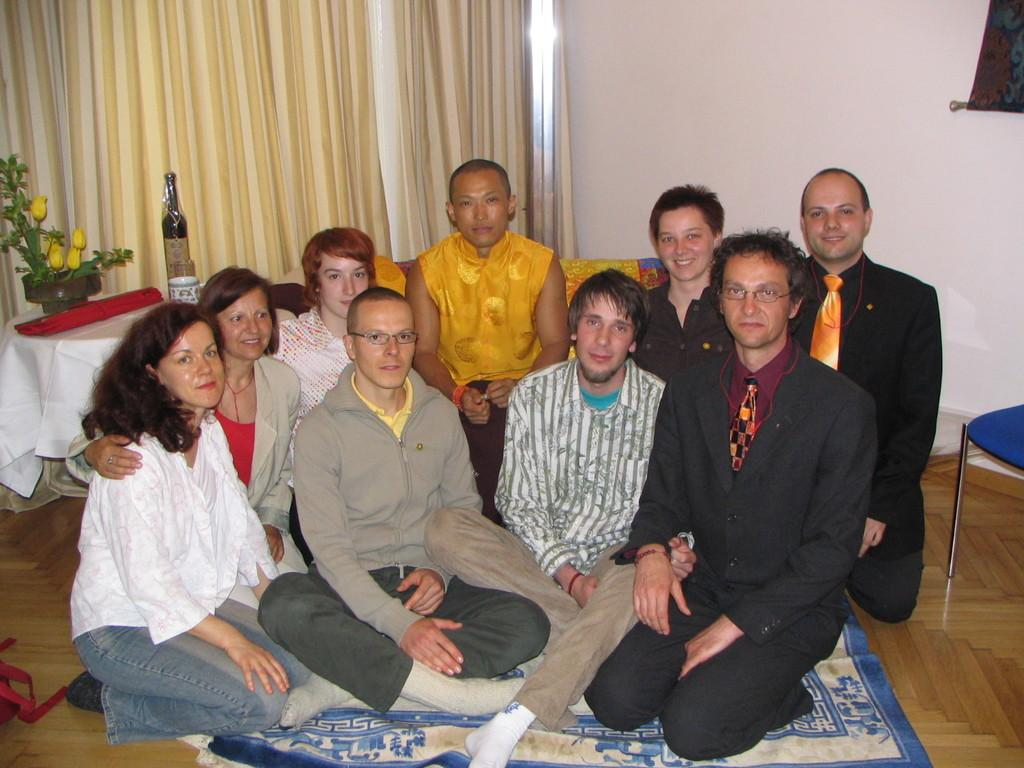What are the people in the image doing? The people in the image are sitting. Can you describe the seating arrangement of one of the people? One person is sitting on a couch. What object can be seen on a table in the image? There is a potted plant on a table. What type of window treatment is visible in the image? There is a curtain visible in the image. What type of base can be seen supporting the couch in the image? There is no base supporting the couch visible in the image; the couch is resting on the floor. How is the string used in the image? There is no string present in the image. What role does the wind play in the image? There is no wind present in the image. 